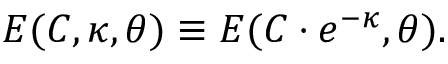Convert formula to latex. <formula><loc_0><loc_0><loc_500><loc_500>E ( C , { \kappa } , { \theta } ) \equiv E ( C \cdot e ^ { - \kappa } , { \theta } ) .</formula> 